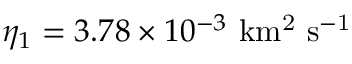<formula> <loc_0><loc_0><loc_500><loc_500>\eta _ { 1 } = 3 . 7 8 \times 1 0 ^ { - 3 } \ k m ^ { 2 } \ s ^ { - 1 }</formula> 